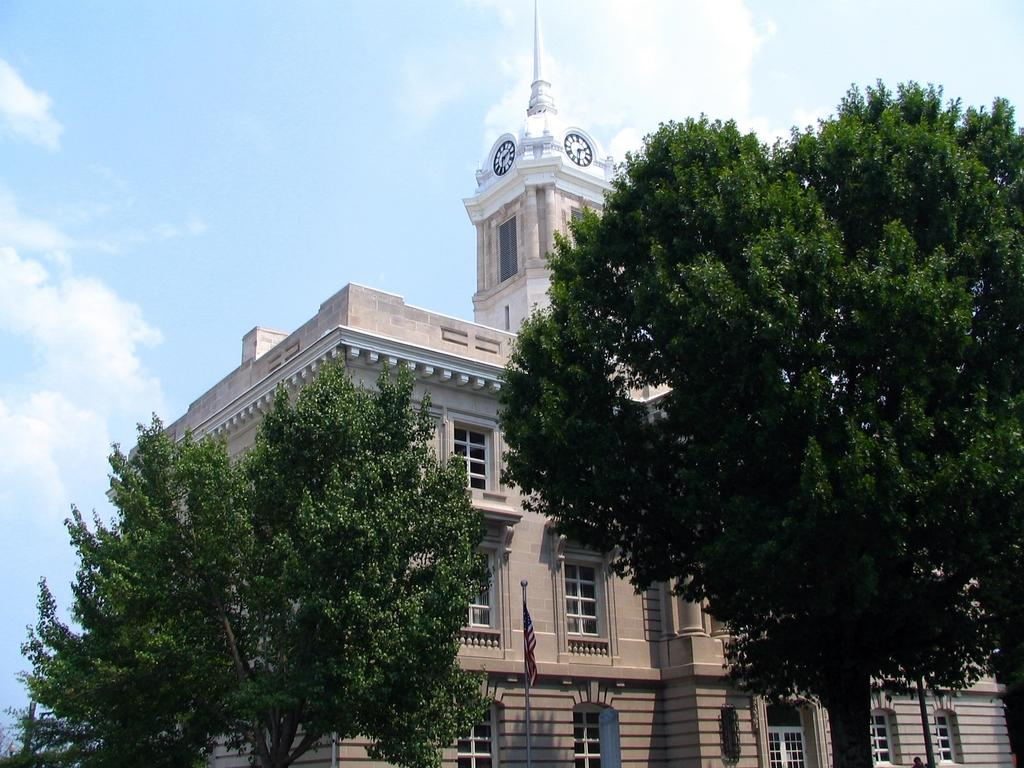What type of natural elements can be seen in the image? There are trees in the image. What type of man-made structures are present in the image? There are buildings in the image. What is the symbolic object visible in the image? There is a flag in the image. What can be seen on the buildings in the image? There are windows in the image. What is visible in the background of the image? The sky is visible in the image, and clouds are present in the sky. What type of sponge can be seen in the image? There is no sponge present in the image. How does the cough affect the buildings in the image? There is no cough present in the image, so it cannot affect the buildings. 